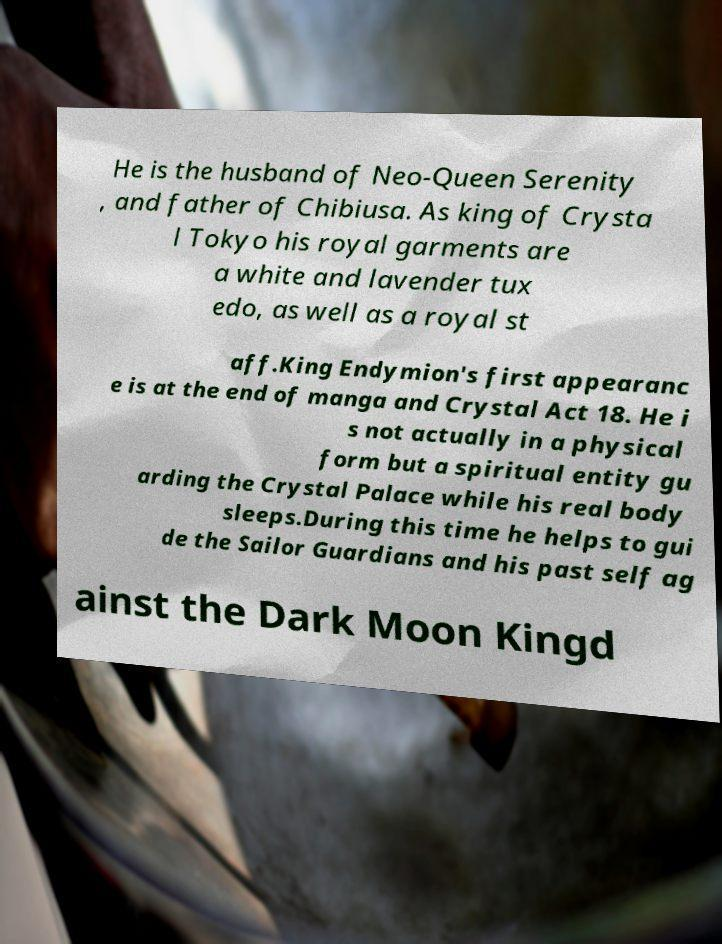Can you accurately transcribe the text from the provided image for me? He is the husband of Neo-Queen Serenity , and father of Chibiusa. As king of Crysta l Tokyo his royal garments are a white and lavender tux edo, as well as a royal st aff.King Endymion's first appearanc e is at the end of manga and Crystal Act 18. He i s not actually in a physical form but a spiritual entity gu arding the Crystal Palace while his real body sleeps.During this time he helps to gui de the Sailor Guardians and his past self ag ainst the Dark Moon Kingd 